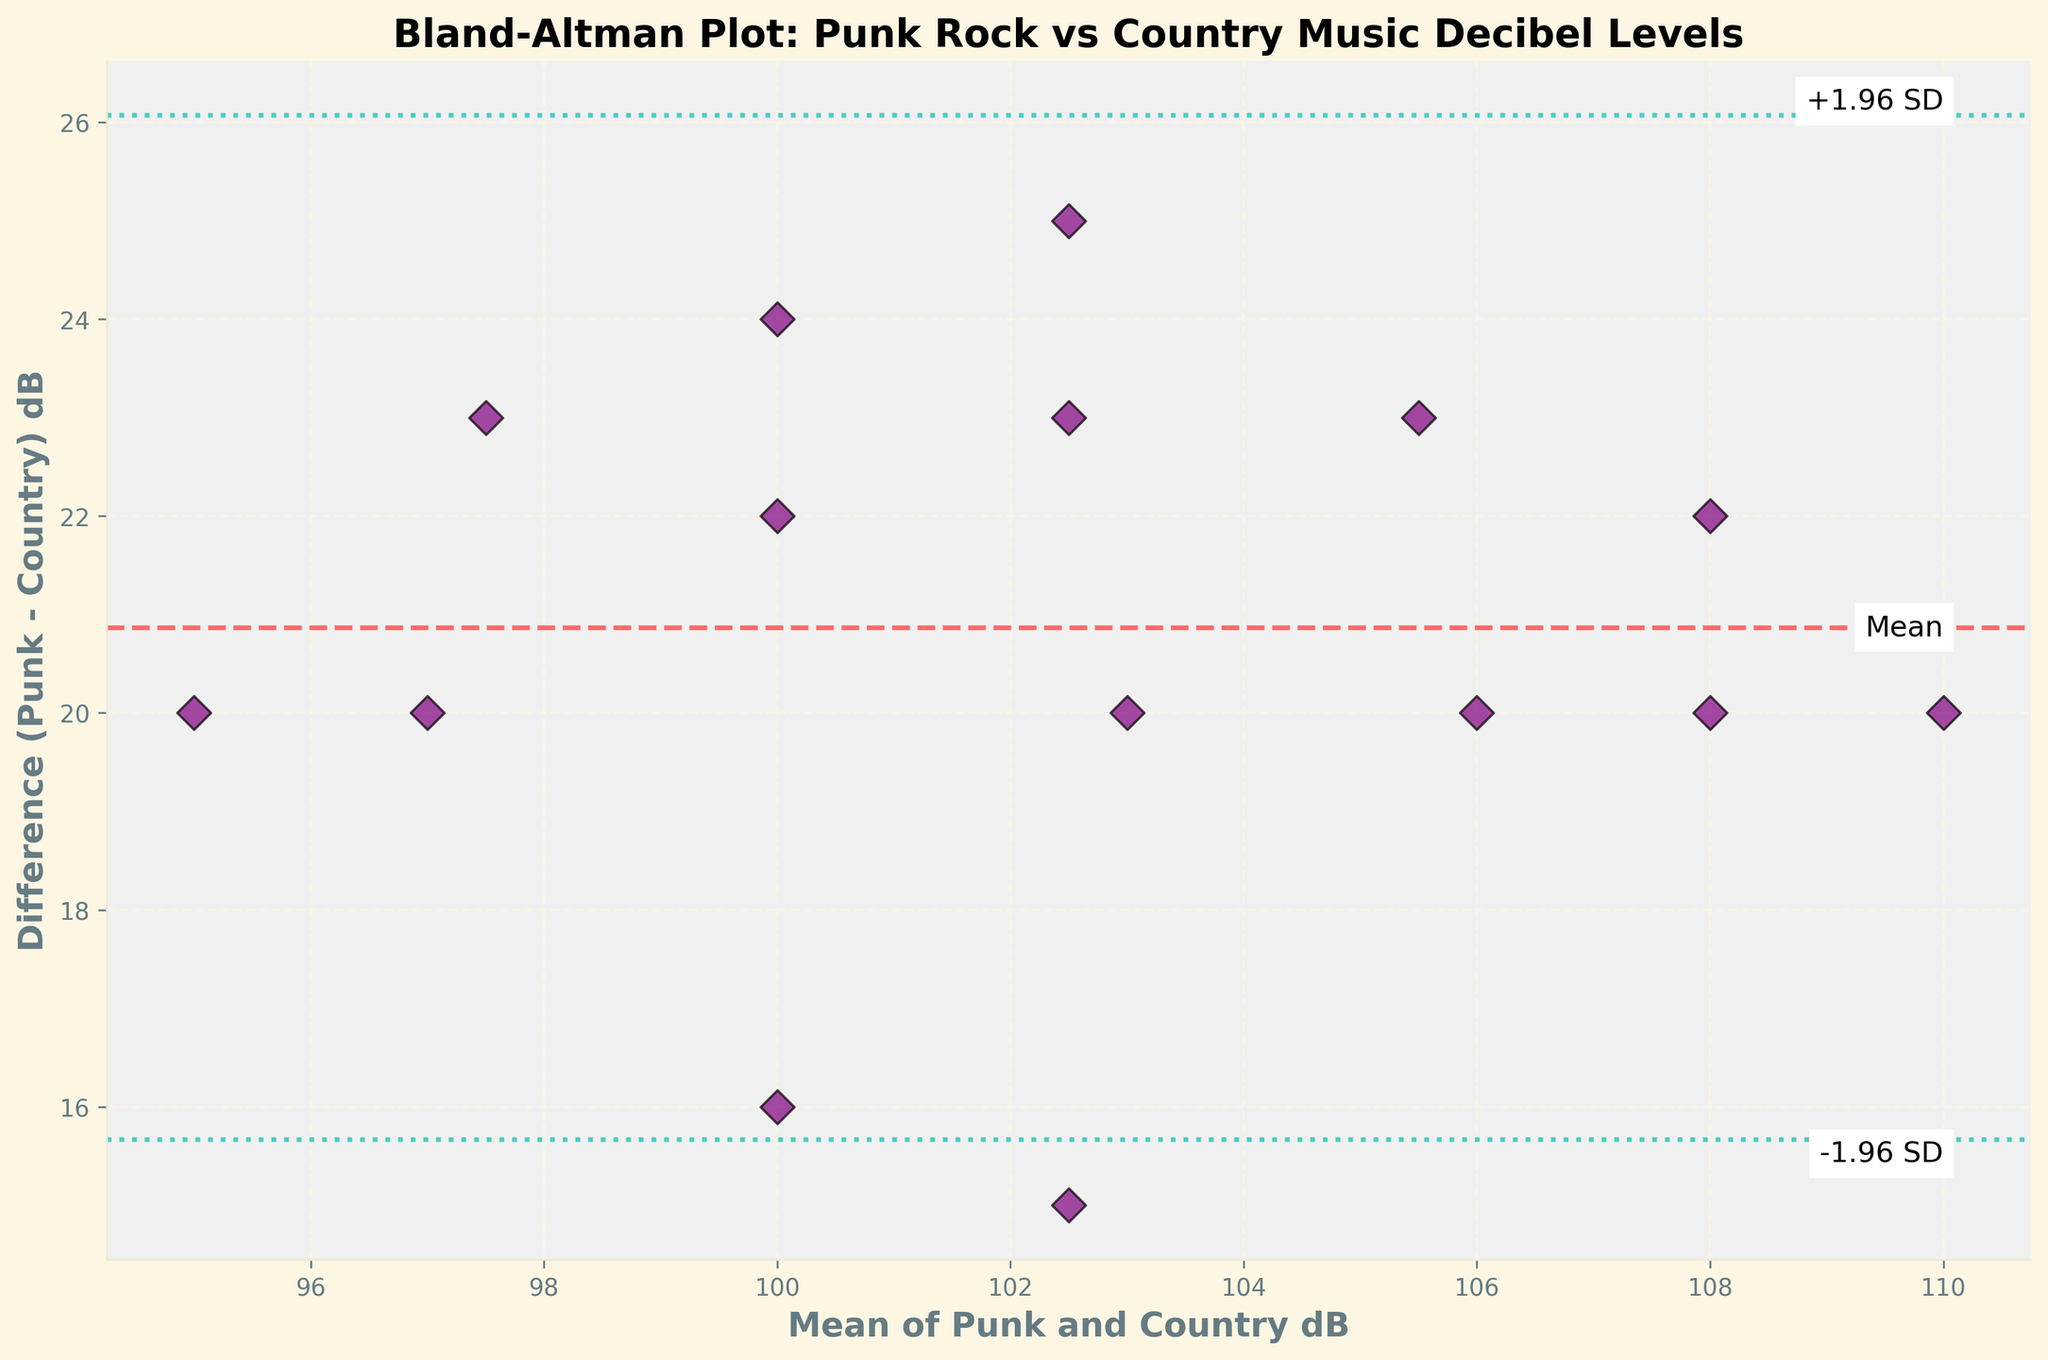What is the title of the figure? The title is located at the top of the figure and provides a summary of what the figure is about. In this case, it states the comparison between punk rock concert and country music festival decibel levels.
Answer: Bland-Altman Plot: Punk Rock vs Country Music Decibel Levels How many data points are displayed in the figure? Count the number of scatter points on the plot. Each point represents a data comparison between the punk rock concerts and country music festivals.
Answer: 15 What color are the lines representing the mean difference and the ±1.96 standard deviation limits? The mean difference line is represented by a dashed red line, while the ±1.96 standard deviation limits are shown with dotted turquoise lines.
Answer: Red and Turquoise What is the mean difference in decibel levels between punk rock concerts and country music festivals? The mean difference line on the plot provides this value. It is the average of the differences between punk and country decibel levels.
Answer: 18 dB What is the range of the average decibel levels on the x-axis? Look at the minimum and maximum values on the x-axis, which represents the mean decibel levels between the two types of events.
Answer: 95 dB to 110 dB How does the difference in decibel levels vary with the average decibel levels? Observe the trend in the scatter plot. As you move from the left side of the plot (lower average decibel levels) to the right side (higher average decibel levels), check if there's a systematic increase or decrease in differences.
Answer: Generally consistent, no clear trend Which data point has the smallest difference between punk rock and country music decibel levels? Identify the point that is closest to the zero line on the y-axis (Difference in dB). This point represents the smallest difference.
Answer: Average dB of 100 (Difference is 3 dB) What is the standard deviation of the differences in decibel levels between punk rock concerts and country music festivals? Calculate the standard deviation of the differences between punk and country decibel levels, represented by the spread of data points around the mean difference line.
Answer: Approximately 6.74 dB How far above and below the mean difference do the ±1.96 standard deviation limits extend? By multiplying the standard deviation by 1.96 and adding/subtracting from the mean difference, we determine the range of variation.
Answer: 13.2 dB above and below 